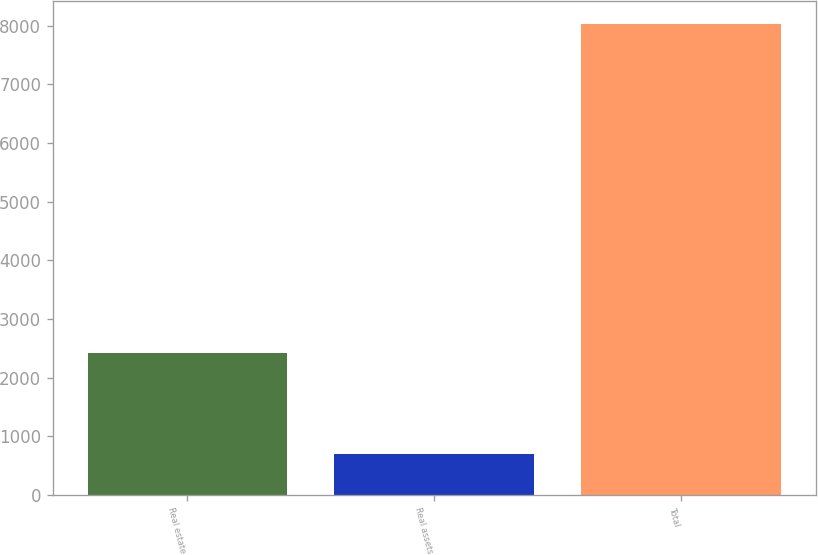Convert chart. <chart><loc_0><loc_0><loc_500><loc_500><bar_chart><fcel>Real estate<fcel>Real assets<fcel>Total<nl><fcel>2424<fcel>706<fcel>8026<nl></chart> 